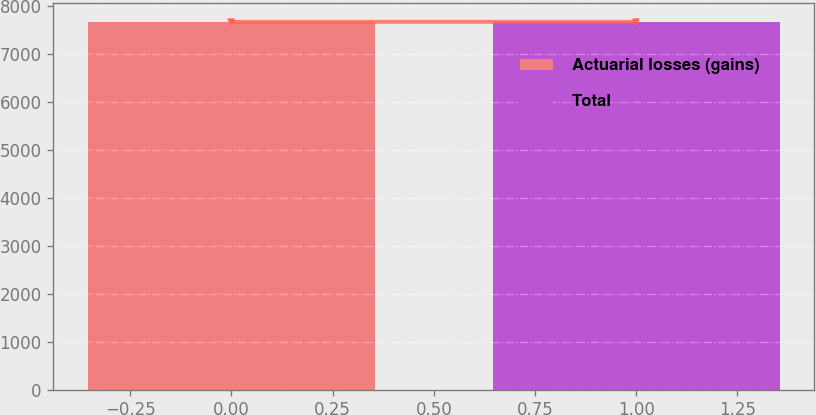Convert chart to OTSL. <chart><loc_0><loc_0><loc_500><loc_500><bar_chart><fcel>Actuarial losses (gains)<fcel>Total<nl><fcel>7664<fcel>7664.1<nl></chart> 